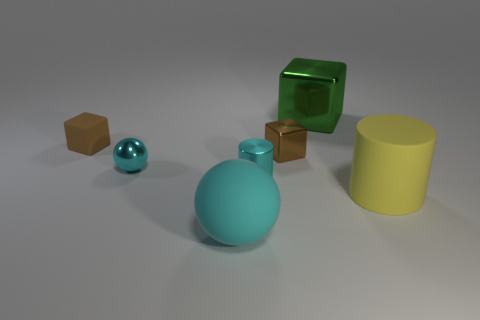How many objects are in the image, and can you describe their shapes? There are six objects in the image. From left to right, there's a small brown cube, a small cyan-colored sphere, a medium-sized cyan sphere, a smaller brown cube, a shiny green cube, and a large yellow cylinder. Could you guess the purpose of this arrangement or what it may symbolize? The arrangement seems arbitrary, suggesting no particular purpose beyond visual interest or demonstrating various geometric shapes and their properties, such as color, material, and reflectivity. If one were to look for symbolism, it might represent diversity and coexistence in terms of variety in shapes and sizes. 